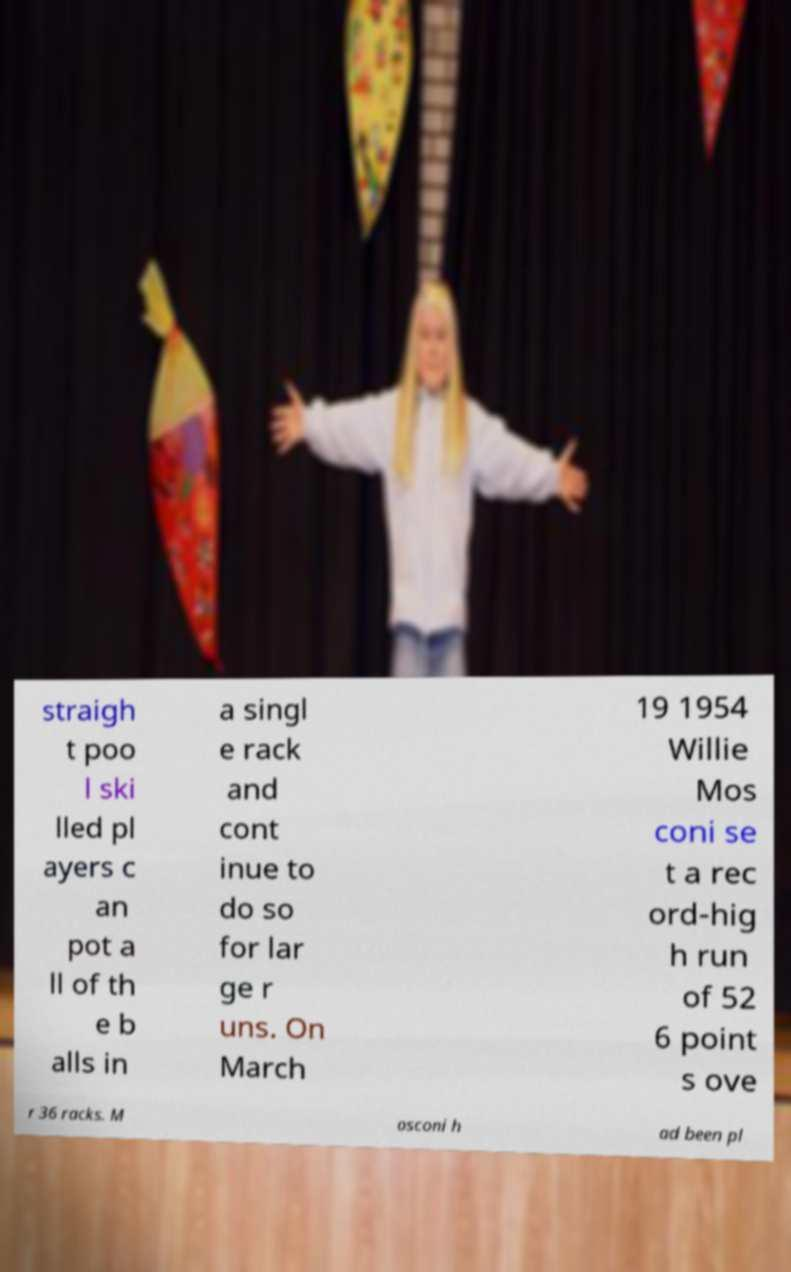There's text embedded in this image that I need extracted. Can you transcribe it verbatim? straigh t poo l ski lled pl ayers c an pot a ll of th e b alls in a singl e rack and cont inue to do so for lar ge r uns. On March 19 1954 Willie Mos coni se t a rec ord-hig h run of 52 6 point s ove r 36 racks. M osconi h ad been pl 